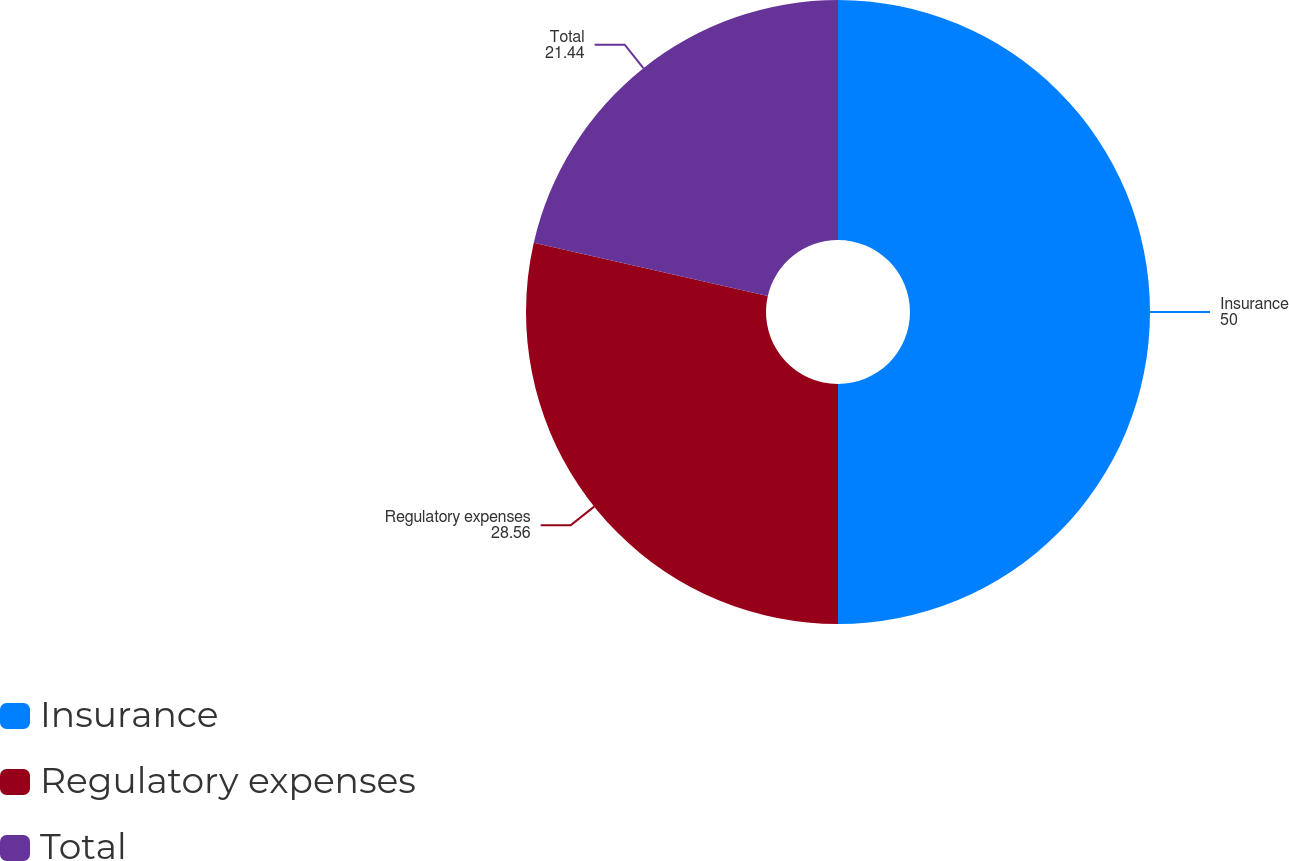Convert chart. <chart><loc_0><loc_0><loc_500><loc_500><pie_chart><fcel>Insurance<fcel>Regulatory expenses<fcel>Total<nl><fcel>50.0%<fcel>28.56%<fcel>21.44%<nl></chart> 